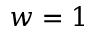Convert formula to latex. <formula><loc_0><loc_0><loc_500><loc_500>w = 1</formula> 